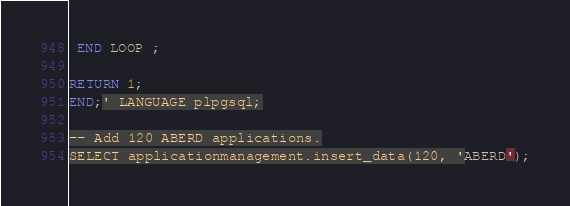Convert code to text. <code><loc_0><loc_0><loc_500><loc_500><_SQL_>
 END LOOP ;

RETURN 1;
END;' LANGUAGE plpgsql;

-- Add 120 ABERD applications.
SELECT applicationmanagement.insert_data(120, 'ABERD');

</code> 